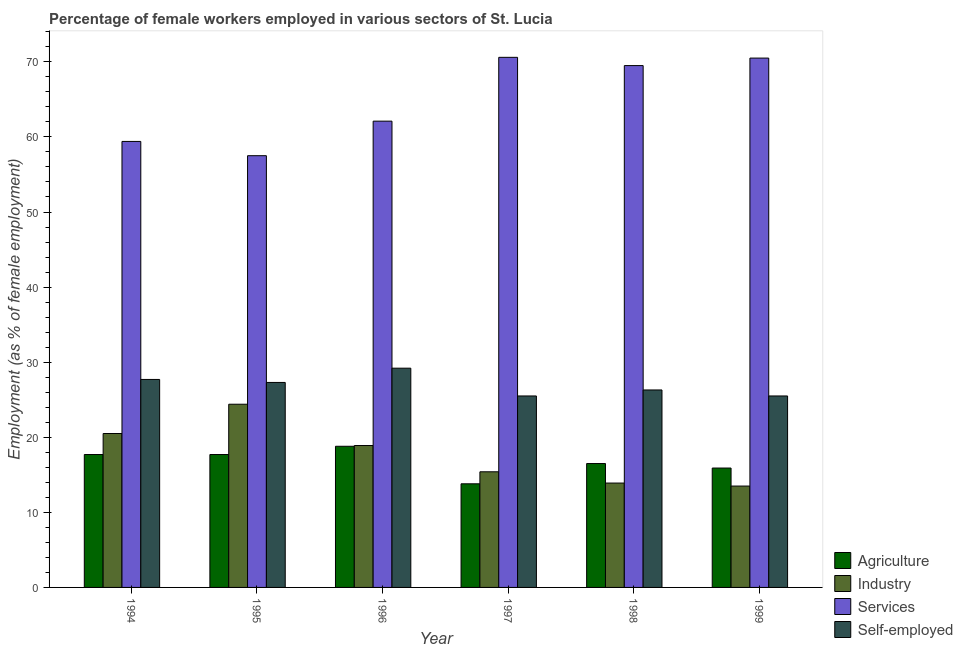How many groups of bars are there?
Provide a succinct answer. 6. Are the number of bars per tick equal to the number of legend labels?
Provide a succinct answer. Yes. Are the number of bars on each tick of the X-axis equal?
Offer a terse response. Yes. How many bars are there on the 5th tick from the left?
Offer a terse response. 4. What is the label of the 2nd group of bars from the left?
Provide a short and direct response. 1995. Across all years, what is the maximum percentage of self employed female workers?
Offer a terse response. 29.2. Across all years, what is the minimum percentage of female workers in agriculture?
Offer a terse response. 13.8. In which year was the percentage of female workers in industry minimum?
Give a very brief answer. 1999. What is the total percentage of female workers in services in the graph?
Provide a short and direct response. 389.6. What is the difference between the percentage of female workers in industry in 1994 and that in 1995?
Keep it short and to the point. -3.9. What is the difference between the percentage of female workers in industry in 1994 and the percentage of female workers in services in 1999?
Make the answer very short. 7. What is the average percentage of female workers in services per year?
Offer a very short reply. 64.93. In the year 1998, what is the difference between the percentage of female workers in agriculture and percentage of self employed female workers?
Provide a short and direct response. 0. What is the ratio of the percentage of female workers in services in 1997 to that in 1999?
Make the answer very short. 1. Is the percentage of self employed female workers in 1994 less than that in 1997?
Offer a very short reply. No. Is the difference between the percentage of female workers in agriculture in 1994 and 1997 greater than the difference between the percentage of female workers in industry in 1994 and 1997?
Your response must be concise. No. What is the difference between the highest and the second highest percentage of female workers in industry?
Provide a short and direct response. 3.9. What is the difference between the highest and the lowest percentage of female workers in industry?
Your answer should be very brief. 10.9. Is the sum of the percentage of female workers in agriculture in 1994 and 1996 greater than the maximum percentage of female workers in services across all years?
Ensure brevity in your answer.  Yes. Is it the case that in every year, the sum of the percentage of female workers in industry and percentage of female workers in services is greater than the sum of percentage of female workers in agriculture and percentage of self employed female workers?
Give a very brief answer. No. What does the 1st bar from the left in 1995 represents?
Ensure brevity in your answer.  Agriculture. What does the 2nd bar from the right in 1997 represents?
Keep it short and to the point. Services. Is it the case that in every year, the sum of the percentage of female workers in agriculture and percentage of female workers in industry is greater than the percentage of female workers in services?
Keep it short and to the point. No. How many years are there in the graph?
Offer a terse response. 6. Does the graph contain grids?
Make the answer very short. No. Where does the legend appear in the graph?
Your response must be concise. Bottom right. How many legend labels are there?
Your answer should be compact. 4. How are the legend labels stacked?
Your response must be concise. Vertical. What is the title of the graph?
Your response must be concise. Percentage of female workers employed in various sectors of St. Lucia. Does "Insurance services" appear as one of the legend labels in the graph?
Provide a succinct answer. No. What is the label or title of the X-axis?
Provide a succinct answer. Year. What is the label or title of the Y-axis?
Your answer should be very brief. Employment (as % of female employment). What is the Employment (as % of female employment) in Agriculture in 1994?
Make the answer very short. 17.7. What is the Employment (as % of female employment) of Industry in 1994?
Give a very brief answer. 20.5. What is the Employment (as % of female employment) of Services in 1994?
Make the answer very short. 59.4. What is the Employment (as % of female employment) in Self-employed in 1994?
Provide a short and direct response. 27.7. What is the Employment (as % of female employment) of Agriculture in 1995?
Offer a terse response. 17.7. What is the Employment (as % of female employment) in Industry in 1995?
Give a very brief answer. 24.4. What is the Employment (as % of female employment) in Services in 1995?
Offer a terse response. 57.5. What is the Employment (as % of female employment) in Self-employed in 1995?
Offer a terse response. 27.3. What is the Employment (as % of female employment) of Agriculture in 1996?
Make the answer very short. 18.8. What is the Employment (as % of female employment) of Industry in 1996?
Give a very brief answer. 18.9. What is the Employment (as % of female employment) of Services in 1996?
Make the answer very short. 62.1. What is the Employment (as % of female employment) of Self-employed in 1996?
Your answer should be compact. 29.2. What is the Employment (as % of female employment) in Agriculture in 1997?
Offer a very short reply. 13.8. What is the Employment (as % of female employment) of Industry in 1997?
Your answer should be very brief. 15.4. What is the Employment (as % of female employment) in Services in 1997?
Provide a short and direct response. 70.6. What is the Employment (as % of female employment) in Industry in 1998?
Provide a succinct answer. 13.9. What is the Employment (as % of female employment) of Services in 1998?
Your answer should be very brief. 69.5. What is the Employment (as % of female employment) in Self-employed in 1998?
Make the answer very short. 26.3. What is the Employment (as % of female employment) in Agriculture in 1999?
Give a very brief answer. 15.9. What is the Employment (as % of female employment) of Services in 1999?
Your answer should be compact. 70.5. What is the Employment (as % of female employment) of Self-employed in 1999?
Provide a succinct answer. 25.5. Across all years, what is the maximum Employment (as % of female employment) of Agriculture?
Offer a very short reply. 18.8. Across all years, what is the maximum Employment (as % of female employment) in Industry?
Your answer should be very brief. 24.4. Across all years, what is the maximum Employment (as % of female employment) of Services?
Your answer should be very brief. 70.6. Across all years, what is the maximum Employment (as % of female employment) of Self-employed?
Offer a very short reply. 29.2. Across all years, what is the minimum Employment (as % of female employment) of Agriculture?
Provide a succinct answer. 13.8. Across all years, what is the minimum Employment (as % of female employment) of Industry?
Offer a terse response. 13.5. Across all years, what is the minimum Employment (as % of female employment) of Services?
Offer a very short reply. 57.5. Across all years, what is the minimum Employment (as % of female employment) of Self-employed?
Provide a succinct answer. 25.5. What is the total Employment (as % of female employment) of Agriculture in the graph?
Provide a succinct answer. 100.4. What is the total Employment (as % of female employment) of Industry in the graph?
Give a very brief answer. 106.6. What is the total Employment (as % of female employment) in Services in the graph?
Give a very brief answer. 389.6. What is the total Employment (as % of female employment) of Self-employed in the graph?
Offer a terse response. 161.5. What is the difference between the Employment (as % of female employment) in Industry in 1994 and that in 1995?
Provide a succinct answer. -3.9. What is the difference between the Employment (as % of female employment) in Services in 1994 and that in 1995?
Make the answer very short. 1.9. What is the difference between the Employment (as % of female employment) of Agriculture in 1994 and that in 1997?
Give a very brief answer. 3.9. What is the difference between the Employment (as % of female employment) of Industry in 1994 and that in 1997?
Offer a terse response. 5.1. What is the difference between the Employment (as % of female employment) in Self-employed in 1994 and that in 1997?
Give a very brief answer. 2.2. What is the difference between the Employment (as % of female employment) of Services in 1994 and that in 1998?
Offer a very short reply. -10.1. What is the difference between the Employment (as % of female employment) in Services in 1994 and that in 1999?
Give a very brief answer. -11.1. What is the difference between the Employment (as % of female employment) in Agriculture in 1995 and that in 1996?
Keep it short and to the point. -1.1. What is the difference between the Employment (as % of female employment) in Self-employed in 1995 and that in 1996?
Your response must be concise. -1.9. What is the difference between the Employment (as % of female employment) in Agriculture in 1995 and that in 1997?
Provide a short and direct response. 3.9. What is the difference between the Employment (as % of female employment) of Industry in 1995 and that in 1999?
Provide a succinct answer. 10.9. What is the difference between the Employment (as % of female employment) in Services in 1995 and that in 1999?
Keep it short and to the point. -13. What is the difference between the Employment (as % of female employment) of Industry in 1996 and that in 1997?
Give a very brief answer. 3.5. What is the difference between the Employment (as % of female employment) in Services in 1996 and that in 1997?
Make the answer very short. -8.5. What is the difference between the Employment (as % of female employment) in Self-employed in 1996 and that in 1997?
Offer a terse response. 3.7. What is the difference between the Employment (as % of female employment) in Self-employed in 1996 and that in 1998?
Provide a short and direct response. 2.9. What is the difference between the Employment (as % of female employment) of Self-employed in 1996 and that in 1999?
Your answer should be very brief. 3.7. What is the difference between the Employment (as % of female employment) in Industry in 1997 and that in 1998?
Your response must be concise. 1.5. What is the difference between the Employment (as % of female employment) of Services in 1997 and that in 1998?
Offer a terse response. 1.1. What is the difference between the Employment (as % of female employment) of Services in 1998 and that in 1999?
Provide a succinct answer. -1. What is the difference between the Employment (as % of female employment) of Agriculture in 1994 and the Employment (as % of female employment) of Industry in 1995?
Make the answer very short. -6.7. What is the difference between the Employment (as % of female employment) of Agriculture in 1994 and the Employment (as % of female employment) of Services in 1995?
Give a very brief answer. -39.8. What is the difference between the Employment (as % of female employment) in Agriculture in 1994 and the Employment (as % of female employment) in Self-employed in 1995?
Make the answer very short. -9.6. What is the difference between the Employment (as % of female employment) of Industry in 1994 and the Employment (as % of female employment) of Services in 1995?
Keep it short and to the point. -37. What is the difference between the Employment (as % of female employment) in Services in 1994 and the Employment (as % of female employment) in Self-employed in 1995?
Keep it short and to the point. 32.1. What is the difference between the Employment (as % of female employment) in Agriculture in 1994 and the Employment (as % of female employment) in Industry in 1996?
Ensure brevity in your answer.  -1.2. What is the difference between the Employment (as % of female employment) in Agriculture in 1994 and the Employment (as % of female employment) in Services in 1996?
Keep it short and to the point. -44.4. What is the difference between the Employment (as % of female employment) in Industry in 1994 and the Employment (as % of female employment) in Services in 1996?
Make the answer very short. -41.6. What is the difference between the Employment (as % of female employment) in Services in 1994 and the Employment (as % of female employment) in Self-employed in 1996?
Provide a succinct answer. 30.2. What is the difference between the Employment (as % of female employment) in Agriculture in 1994 and the Employment (as % of female employment) in Industry in 1997?
Provide a succinct answer. 2.3. What is the difference between the Employment (as % of female employment) of Agriculture in 1994 and the Employment (as % of female employment) of Services in 1997?
Your answer should be very brief. -52.9. What is the difference between the Employment (as % of female employment) of Industry in 1994 and the Employment (as % of female employment) of Services in 1997?
Your response must be concise. -50.1. What is the difference between the Employment (as % of female employment) in Industry in 1994 and the Employment (as % of female employment) in Self-employed in 1997?
Give a very brief answer. -5. What is the difference between the Employment (as % of female employment) in Services in 1994 and the Employment (as % of female employment) in Self-employed in 1997?
Offer a very short reply. 33.9. What is the difference between the Employment (as % of female employment) in Agriculture in 1994 and the Employment (as % of female employment) in Services in 1998?
Offer a very short reply. -51.8. What is the difference between the Employment (as % of female employment) in Industry in 1994 and the Employment (as % of female employment) in Services in 1998?
Keep it short and to the point. -49. What is the difference between the Employment (as % of female employment) in Industry in 1994 and the Employment (as % of female employment) in Self-employed in 1998?
Your response must be concise. -5.8. What is the difference between the Employment (as % of female employment) in Services in 1994 and the Employment (as % of female employment) in Self-employed in 1998?
Provide a short and direct response. 33.1. What is the difference between the Employment (as % of female employment) in Agriculture in 1994 and the Employment (as % of female employment) in Services in 1999?
Make the answer very short. -52.8. What is the difference between the Employment (as % of female employment) in Industry in 1994 and the Employment (as % of female employment) in Self-employed in 1999?
Make the answer very short. -5. What is the difference between the Employment (as % of female employment) in Services in 1994 and the Employment (as % of female employment) in Self-employed in 1999?
Offer a very short reply. 33.9. What is the difference between the Employment (as % of female employment) of Agriculture in 1995 and the Employment (as % of female employment) of Industry in 1996?
Give a very brief answer. -1.2. What is the difference between the Employment (as % of female employment) of Agriculture in 1995 and the Employment (as % of female employment) of Services in 1996?
Provide a succinct answer. -44.4. What is the difference between the Employment (as % of female employment) of Agriculture in 1995 and the Employment (as % of female employment) of Self-employed in 1996?
Your answer should be compact. -11.5. What is the difference between the Employment (as % of female employment) of Industry in 1995 and the Employment (as % of female employment) of Services in 1996?
Provide a short and direct response. -37.7. What is the difference between the Employment (as % of female employment) of Services in 1995 and the Employment (as % of female employment) of Self-employed in 1996?
Your answer should be compact. 28.3. What is the difference between the Employment (as % of female employment) in Agriculture in 1995 and the Employment (as % of female employment) in Services in 1997?
Make the answer very short. -52.9. What is the difference between the Employment (as % of female employment) of Agriculture in 1995 and the Employment (as % of female employment) of Self-employed in 1997?
Keep it short and to the point. -7.8. What is the difference between the Employment (as % of female employment) in Industry in 1995 and the Employment (as % of female employment) in Services in 1997?
Your answer should be compact. -46.2. What is the difference between the Employment (as % of female employment) in Industry in 1995 and the Employment (as % of female employment) in Self-employed in 1997?
Give a very brief answer. -1.1. What is the difference between the Employment (as % of female employment) in Agriculture in 1995 and the Employment (as % of female employment) in Industry in 1998?
Keep it short and to the point. 3.8. What is the difference between the Employment (as % of female employment) of Agriculture in 1995 and the Employment (as % of female employment) of Services in 1998?
Ensure brevity in your answer.  -51.8. What is the difference between the Employment (as % of female employment) of Agriculture in 1995 and the Employment (as % of female employment) of Self-employed in 1998?
Your answer should be very brief. -8.6. What is the difference between the Employment (as % of female employment) of Industry in 1995 and the Employment (as % of female employment) of Services in 1998?
Provide a succinct answer. -45.1. What is the difference between the Employment (as % of female employment) of Industry in 1995 and the Employment (as % of female employment) of Self-employed in 1998?
Offer a terse response. -1.9. What is the difference between the Employment (as % of female employment) in Services in 1995 and the Employment (as % of female employment) in Self-employed in 1998?
Provide a short and direct response. 31.2. What is the difference between the Employment (as % of female employment) of Agriculture in 1995 and the Employment (as % of female employment) of Industry in 1999?
Offer a very short reply. 4.2. What is the difference between the Employment (as % of female employment) of Agriculture in 1995 and the Employment (as % of female employment) of Services in 1999?
Your answer should be very brief. -52.8. What is the difference between the Employment (as % of female employment) in Industry in 1995 and the Employment (as % of female employment) in Services in 1999?
Your answer should be very brief. -46.1. What is the difference between the Employment (as % of female employment) in Services in 1995 and the Employment (as % of female employment) in Self-employed in 1999?
Offer a very short reply. 32. What is the difference between the Employment (as % of female employment) of Agriculture in 1996 and the Employment (as % of female employment) of Services in 1997?
Make the answer very short. -51.8. What is the difference between the Employment (as % of female employment) in Agriculture in 1996 and the Employment (as % of female employment) in Self-employed in 1997?
Make the answer very short. -6.7. What is the difference between the Employment (as % of female employment) of Industry in 1996 and the Employment (as % of female employment) of Services in 1997?
Your answer should be very brief. -51.7. What is the difference between the Employment (as % of female employment) of Industry in 1996 and the Employment (as % of female employment) of Self-employed in 1997?
Your answer should be very brief. -6.6. What is the difference between the Employment (as % of female employment) of Services in 1996 and the Employment (as % of female employment) of Self-employed in 1997?
Provide a succinct answer. 36.6. What is the difference between the Employment (as % of female employment) in Agriculture in 1996 and the Employment (as % of female employment) in Services in 1998?
Make the answer very short. -50.7. What is the difference between the Employment (as % of female employment) in Industry in 1996 and the Employment (as % of female employment) in Services in 1998?
Your answer should be very brief. -50.6. What is the difference between the Employment (as % of female employment) in Services in 1996 and the Employment (as % of female employment) in Self-employed in 1998?
Offer a very short reply. 35.8. What is the difference between the Employment (as % of female employment) in Agriculture in 1996 and the Employment (as % of female employment) in Industry in 1999?
Give a very brief answer. 5.3. What is the difference between the Employment (as % of female employment) of Agriculture in 1996 and the Employment (as % of female employment) of Services in 1999?
Provide a short and direct response. -51.7. What is the difference between the Employment (as % of female employment) of Industry in 1996 and the Employment (as % of female employment) of Services in 1999?
Provide a short and direct response. -51.6. What is the difference between the Employment (as % of female employment) of Industry in 1996 and the Employment (as % of female employment) of Self-employed in 1999?
Your response must be concise. -6.6. What is the difference between the Employment (as % of female employment) in Services in 1996 and the Employment (as % of female employment) in Self-employed in 1999?
Provide a short and direct response. 36.6. What is the difference between the Employment (as % of female employment) in Agriculture in 1997 and the Employment (as % of female employment) in Services in 1998?
Your answer should be compact. -55.7. What is the difference between the Employment (as % of female employment) in Industry in 1997 and the Employment (as % of female employment) in Services in 1998?
Provide a succinct answer. -54.1. What is the difference between the Employment (as % of female employment) in Services in 1997 and the Employment (as % of female employment) in Self-employed in 1998?
Make the answer very short. 44.3. What is the difference between the Employment (as % of female employment) in Agriculture in 1997 and the Employment (as % of female employment) in Services in 1999?
Provide a succinct answer. -56.7. What is the difference between the Employment (as % of female employment) in Industry in 1997 and the Employment (as % of female employment) in Services in 1999?
Keep it short and to the point. -55.1. What is the difference between the Employment (as % of female employment) of Services in 1997 and the Employment (as % of female employment) of Self-employed in 1999?
Offer a very short reply. 45.1. What is the difference between the Employment (as % of female employment) in Agriculture in 1998 and the Employment (as % of female employment) in Services in 1999?
Your answer should be compact. -54. What is the difference between the Employment (as % of female employment) in Industry in 1998 and the Employment (as % of female employment) in Services in 1999?
Ensure brevity in your answer.  -56.6. What is the difference between the Employment (as % of female employment) in Services in 1998 and the Employment (as % of female employment) in Self-employed in 1999?
Provide a succinct answer. 44. What is the average Employment (as % of female employment) of Agriculture per year?
Offer a very short reply. 16.73. What is the average Employment (as % of female employment) of Industry per year?
Make the answer very short. 17.77. What is the average Employment (as % of female employment) in Services per year?
Give a very brief answer. 64.93. What is the average Employment (as % of female employment) of Self-employed per year?
Your answer should be compact. 26.92. In the year 1994, what is the difference between the Employment (as % of female employment) of Agriculture and Employment (as % of female employment) of Industry?
Give a very brief answer. -2.8. In the year 1994, what is the difference between the Employment (as % of female employment) in Agriculture and Employment (as % of female employment) in Services?
Make the answer very short. -41.7. In the year 1994, what is the difference between the Employment (as % of female employment) in Agriculture and Employment (as % of female employment) in Self-employed?
Ensure brevity in your answer.  -10. In the year 1994, what is the difference between the Employment (as % of female employment) in Industry and Employment (as % of female employment) in Services?
Make the answer very short. -38.9. In the year 1994, what is the difference between the Employment (as % of female employment) of Industry and Employment (as % of female employment) of Self-employed?
Your response must be concise. -7.2. In the year 1994, what is the difference between the Employment (as % of female employment) in Services and Employment (as % of female employment) in Self-employed?
Provide a short and direct response. 31.7. In the year 1995, what is the difference between the Employment (as % of female employment) of Agriculture and Employment (as % of female employment) of Services?
Your answer should be very brief. -39.8. In the year 1995, what is the difference between the Employment (as % of female employment) of Agriculture and Employment (as % of female employment) of Self-employed?
Give a very brief answer. -9.6. In the year 1995, what is the difference between the Employment (as % of female employment) of Industry and Employment (as % of female employment) of Services?
Offer a terse response. -33.1. In the year 1995, what is the difference between the Employment (as % of female employment) of Services and Employment (as % of female employment) of Self-employed?
Make the answer very short. 30.2. In the year 1996, what is the difference between the Employment (as % of female employment) of Agriculture and Employment (as % of female employment) of Services?
Offer a very short reply. -43.3. In the year 1996, what is the difference between the Employment (as % of female employment) of Agriculture and Employment (as % of female employment) of Self-employed?
Ensure brevity in your answer.  -10.4. In the year 1996, what is the difference between the Employment (as % of female employment) in Industry and Employment (as % of female employment) in Services?
Your answer should be compact. -43.2. In the year 1996, what is the difference between the Employment (as % of female employment) of Industry and Employment (as % of female employment) of Self-employed?
Provide a succinct answer. -10.3. In the year 1996, what is the difference between the Employment (as % of female employment) in Services and Employment (as % of female employment) in Self-employed?
Offer a terse response. 32.9. In the year 1997, what is the difference between the Employment (as % of female employment) of Agriculture and Employment (as % of female employment) of Industry?
Make the answer very short. -1.6. In the year 1997, what is the difference between the Employment (as % of female employment) in Agriculture and Employment (as % of female employment) in Services?
Your answer should be compact. -56.8. In the year 1997, what is the difference between the Employment (as % of female employment) of Industry and Employment (as % of female employment) of Services?
Keep it short and to the point. -55.2. In the year 1997, what is the difference between the Employment (as % of female employment) in Services and Employment (as % of female employment) in Self-employed?
Ensure brevity in your answer.  45.1. In the year 1998, what is the difference between the Employment (as % of female employment) in Agriculture and Employment (as % of female employment) in Industry?
Provide a succinct answer. 2.6. In the year 1998, what is the difference between the Employment (as % of female employment) in Agriculture and Employment (as % of female employment) in Services?
Offer a terse response. -53. In the year 1998, what is the difference between the Employment (as % of female employment) in Industry and Employment (as % of female employment) in Services?
Your answer should be compact. -55.6. In the year 1998, what is the difference between the Employment (as % of female employment) in Services and Employment (as % of female employment) in Self-employed?
Your response must be concise. 43.2. In the year 1999, what is the difference between the Employment (as % of female employment) in Agriculture and Employment (as % of female employment) in Industry?
Provide a short and direct response. 2.4. In the year 1999, what is the difference between the Employment (as % of female employment) of Agriculture and Employment (as % of female employment) of Services?
Offer a terse response. -54.6. In the year 1999, what is the difference between the Employment (as % of female employment) of Industry and Employment (as % of female employment) of Services?
Offer a very short reply. -57. In the year 1999, what is the difference between the Employment (as % of female employment) in Industry and Employment (as % of female employment) in Self-employed?
Your answer should be very brief. -12. In the year 1999, what is the difference between the Employment (as % of female employment) of Services and Employment (as % of female employment) of Self-employed?
Provide a short and direct response. 45. What is the ratio of the Employment (as % of female employment) of Agriculture in 1994 to that in 1995?
Give a very brief answer. 1. What is the ratio of the Employment (as % of female employment) in Industry in 1994 to that in 1995?
Offer a terse response. 0.84. What is the ratio of the Employment (as % of female employment) in Services in 1994 to that in 1995?
Your answer should be very brief. 1.03. What is the ratio of the Employment (as % of female employment) in Self-employed in 1994 to that in 1995?
Ensure brevity in your answer.  1.01. What is the ratio of the Employment (as % of female employment) in Agriculture in 1994 to that in 1996?
Offer a very short reply. 0.94. What is the ratio of the Employment (as % of female employment) in Industry in 1994 to that in 1996?
Provide a succinct answer. 1.08. What is the ratio of the Employment (as % of female employment) of Services in 1994 to that in 1996?
Provide a short and direct response. 0.96. What is the ratio of the Employment (as % of female employment) of Self-employed in 1994 to that in 1996?
Provide a short and direct response. 0.95. What is the ratio of the Employment (as % of female employment) of Agriculture in 1994 to that in 1997?
Offer a terse response. 1.28. What is the ratio of the Employment (as % of female employment) in Industry in 1994 to that in 1997?
Provide a succinct answer. 1.33. What is the ratio of the Employment (as % of female employment) in Services in 1994 to that in 1997?
Offer a terse response. 0.84. What is the ratio of the Employment (as % of female employment) of Self-employed in 1994 to that in 1997?
Ensure brevity in your answer.  1.09. What is the ratio of the Employment (as % of female employment) of Agriculture in 1994 to that in 1998?
Make the answer very short. 1.07. What is the ratio of the Employment (as % of female employment) of Industry in 1994 to that in 1998?
Offer a very short reply. 1.47. What is the ratio of the Employment (as % of female employment) in Services in 1994 to that in 1998?
Provide a succinct answer. 0.85. What is the ratio of the Employment (as % of female employment) in Self-employed in 1994 to that in 1998?
Your response must be concise. 1.05. What is the ratio of the Employment (as % of female employment) in Agriculture in 1994 to that in 1999?
Ensure brevity in your answer.  1.11. What is the ratio of the Employment (as % of female employment) in Industry in 1994 to that in 1999?
Keep it short and to the point. 1.52. What is the ratio of the Employment (as % of female employment) of Services in 1994 to that in 1999?
Your answer should be compact. 0.84. What is the ratio of the Employment (as % of female employment) of Self-employed in 1994 to that in 1999?
Ensure brevity in your answer.  1.09. What is the ratio of the Employment (as % of female employment) in Agriculture in 1995 to that in 1996?
Offer a terse response. 0.94. What is the ratio of the Employment (as % of female employment) of Industry in 1995 to that in 1996?
Provide a short and direct response. 1.29. What is the ratio of the Employment (as % of female employment) in Services in 1995 to that in 1996?
Provide a short and direct response. 0.93. What is the ratio of the Employment (as % of female employment) in Self-employed in 1995 to that in 1996?
Ensure brevity in your answer.  0.93. What is the ratio of the Employment (as % of female employment) of Agriculture in 1995 to that in 1997?
Offer a very short reply. 1.28. What is the ratio of the Employment (as % of female employment) of Industry in 1995 to that in 1997?
Provide a short and direct response. 1.58. What is the ratio of the Employment (as % of female employment) in Services in 1995 to that in 1997?
Your answer should be very brief. 0.81. What is the ratio of the Employment (as % of female employment) of Self-employed in 1995 to that in 1997?
Make the answer very short. 1.07. What is the ratio of the Employment (as % of female employment) of Agriculture in 1995 to that in 1998?
Your response must be concise. 1.07. What is the ratio of the Employment (as % of female employment) of Industry in 1995 to that in 1998?
Make the answer very short. 1.76. What is the ratio of the Employment (as % of female employment) in Services in 1995 to that in 1998?
Ensure brevity in your answer.  0.83. What is the ratio of the Employment (as % of female employment) in Self-employed in 1995 to that in 1998?
Offer a terse response. 1.04. What is the ratio of the Employment (as % of female employment) in Agriculture in 1995 to that in 1999?
Your response must be concise. 1.11. What is the ratio of the Employment (as % of female employment) of Industry in 1995 to that in 1999?
Your answer should be very brief. 1.81. What is the ratio of the Employment (as % of female employment) of Services in 1995 to that in 1999?
Offer a terse response. 0.82. What is the ratio of the Employment (as % of female employment) in Self-employed in 1995 to that in 1999?
Offer a terse response. 1.07. What is the ratio of the Employment (as % of female employment) of Agriculture in 1996 to that in 1997?
Your answer should be compact. 1.36. What is the ratio of the Employment (as % of female employment) in Industry in 1996 to that in 1997?
Ensure brevity in your answer.  1.23. What is the ratio of the Employment (as % of female employment) of Services in 1996 to that in 1997?
Provide a succinct answer. 0.88. What is the ratio of the Employment (as % of female employment) in Self-employed in 1996 to that in 1997?
Provide a short and direct response. 1.15. What is the ratio of the Employment (as % of female employment) in Agriculture in 1996 to that in 1998?
Your response must be concise. 1.14. What is the ratio of the Employment (as % of female employment) of Industry in 1996 to that in 1998?
Provide a short and direct response. 1.36. What is the ratio of the Employment (as % of female employment) in Services in 1996 to that in 1998?
Keep it short and to the point. 0.89. What is the ratio of the Employment (as % of female employment) of Self-employed in 1996 to that in 1998?
Give a very brief answer. 1.11. What is the ratio of the Employment (as % of female employment) of Agriculture in 1996 to that in 1999?
Your answer should be compact. 1.18. What is the ratio of the Employment (as % of female employment) of Services in 1996 to that in 1999?
Keep it short and to the point. 0.88. What is the ratio of the Employment (as % of female employment) of Self-employed in 1996 to that in 1999?
Ensure brevity in your answer.  1.15. What is the ratio of the Employment (as % of female employment) in Agriculture in 1997 to that in 1998?
Provide a short and direct response. 0.84. What is the ratio of the Employment (as % of female employment) of Industry in 1997 to that in 1998?
Give a very brief answer. 1.11. What is the ratio of the Employment (as % of female employment) of Services in 1997 to that in 1998?
Ensure brevity in your answer.  1.02. What is the ratio of the Employment (as % of female employment) in Self-employed in 1997 to that in 1998?
Keep it short and to the point. 0.97. What is the ratio of the Employment (as % of female employment) of Agriculture in 1997 to that in 1999?
Provide a short and direct response. 0.87. What is the ratio of the Employment (as % of female employment) of Industry in 1997 to that in 1999?
Your response must be concise. 1.14. What is the ratio of the Employment (as % of female employment) of Services in 1997 to that in 1999?
Your response must be concise. 1. What is the ratio of the Employment (as % of female employment) in Agriculture in 1998 to that in 1999?
Provide a succinct answer. 1.04. What is the ratio of the Employment (as % of female employment) of Industry in 1998 to that in 1999?
Offer a very short reply. 1.03. What is the ratio of the Employment (as % of female employment) of Services in 1998 to that in 1999?
Your answer should be compact. 0.99. What is the ratio of the Employment (as % of female employment) of Self-employed in 1998 to that in 1999?
Your response must be concise. 1.03. What is the difference between the highest and the second highest Employment (as % of female employment) in Agriculture?
Your response must be concise. 1.1. What is the difference between the highest and the second highest Employment (as % of female employment) of Industry?
Your response must be concise. 3.9. What is the difference between the highest and the second highest Employment (as % of female employment) of Services?
Ensure brevity in your answer.  0.1. What is the difference between the highest and the lowest Employment (as % of female employment) of Agriculture?
Your answer should be compact. 5. What is the difference between the highest and the lowest Employment (as % of female employment) of Industry?
Provide a short and direct response. 10.9. What is the difference between the highest and the lowest Employment (as % of female employment) in Self-employed?
Make the answer very short. 3.7. 